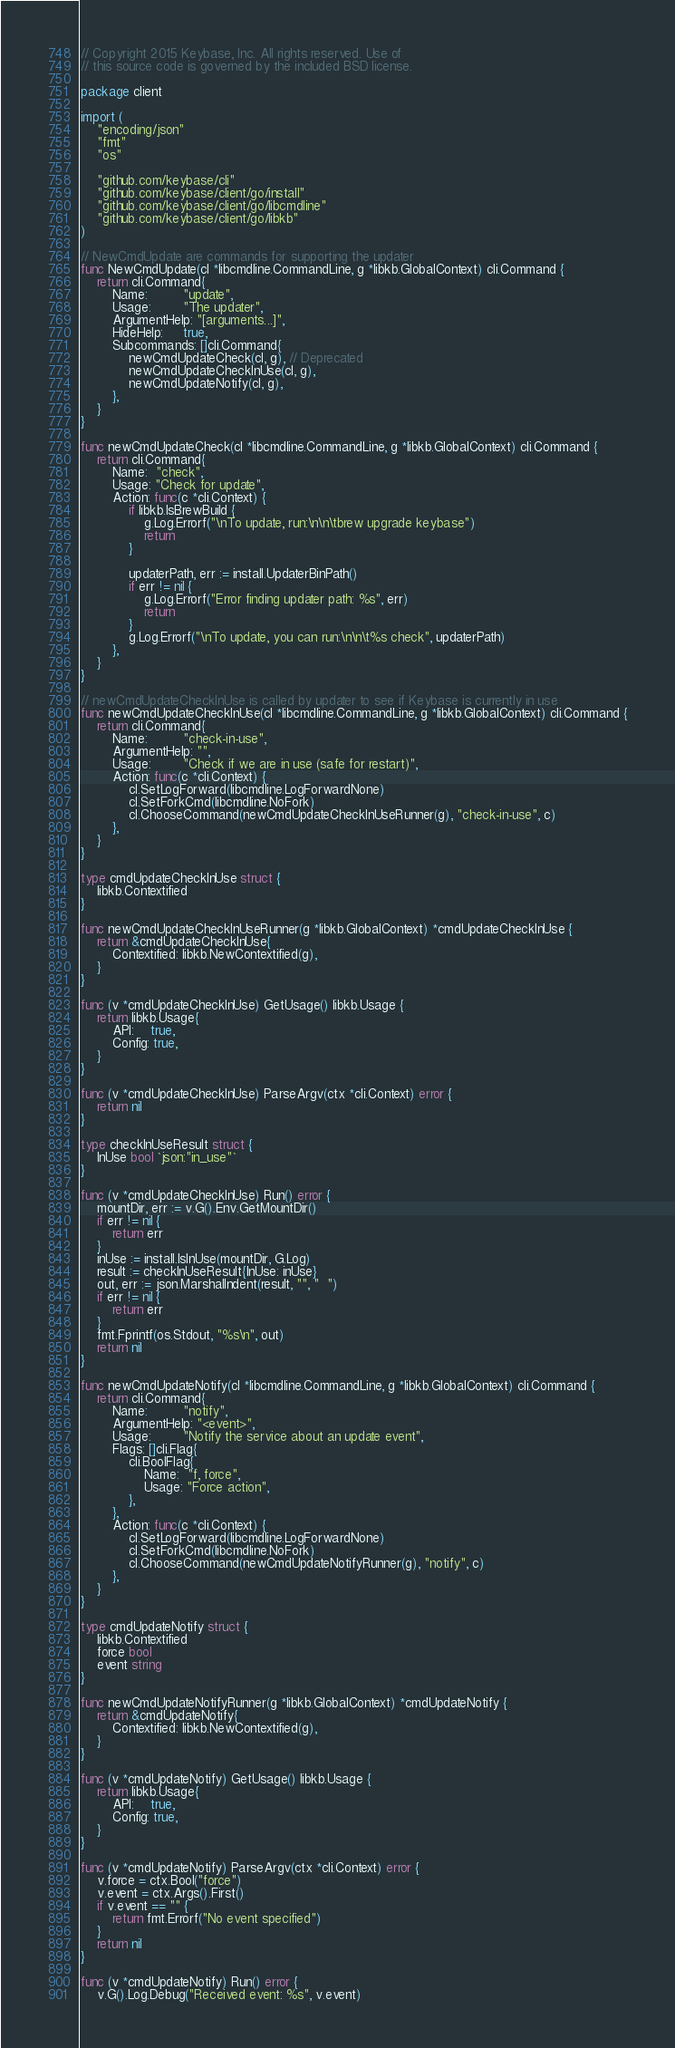<code> <loc_0><loc_0><loc_500><loc_500><_Go_>// Copyright 2015 Keybase, Inc. All rights reserved. Use of
// this source code is governed by the included BSD license.

package client

import (
	"encoding/json"
	"fmt"
	"os"

	"github.com/keybase/cli"
	"github.com/keybase/client/go/install"
	"github.com/keybase/client/go/libcmdline"
	"github.com/keybase/client/go/libkb"
)

// NewCmdUpdate are commands for supporting the updater
func NewCmdUpdate(cl *libcmdline.CommandLine, g *libkb.GlobalContext) cli.Command {
	return cli.Command{
		Name:         "update",
		Usage:        "The updater",
		ArgumentHelp: "[arguments...]",
		HideHelp:     true,
		Subcommands: []cli.Command{
			newCmdUpdateCheck(cl, g), // Deprecated
			newCmdUpdateCheckInUse(cl, g),
			newCmdUpdateNotify(cl, g),
		},
	}
}

func newCmdUpdateCheck(cl *libcmdline.CommandLine, g *libkb.GlobalContext) cli.Command {
	return cli.Command{
		Name:  "check",
		Usage: "Check for update",
		Action: func(c *cli.Context) {
			if libkb.IsBrewBuild {
				g.Log.Errorf("\nTo update, run:\n\n\tbrew upgrade keybase")
				return
			}

			updaterPath, err := install.UpdaterBinPath()
			if err != nil {
				g.Log.Errorf("Error finding updater path: %s", err)
				return
			}
			g.Log.Errorf("\nTo update, you can run:\n\n\t%s check", updaterPath)
		},
	}
}

// newCmdUpdateCheckInUse is called by updater to see if Keybase is currently in use
func newCmdUpdateCheckInUse(cl *libcmdline.CommandLine, g *libkb.GlobalContext) cli.Command {
	return cli.Command{
		Name:         "check-in-use",
		ArgumentHelp: "",
		Usage:        "Check if we are in use (safe for restart)",
		Action: func(c *cli.Context) {
			cl.SetLogForward(libcmdline.LogForwardNone)
			cl.SetForkCmd(libcmdline.NoFork)
			cl.ChooseCommand(newCmdUpdateCheckInUseRunner(g), "check-in-use", c)
		},
	}
}

type cmdUpdateCheckInUse struct {
	libkb.Contextified
}

func newCmdUpdateCheckInUseRunner(g *libkb.GlobalContext) *cmdUpdateCheckInUse {
	return &cmdUpdateCheckInUse{
		Contextified: libkb.NewContextified(g),
	}
}

func (v *cmdUpdateCheckInUse) GetUsage() libkb.Usage {
	return libkb.Usage{
		API:    true,
		Config: true,
	}
}

func (v *cmdUpdateCheckInUse) ParseArgv(ctx *cli.Context) error {
	return nil
}

type checkInUseResult struct {
	InUse bool `json:"in_use"`
}

func (v *cmdUpdateCheckInUse) Run() error {
	mountDir, err := v.G().Env.GetMountDir()
	if err != nil {
		return err
	}
	inUse := install.IsInUse(mountDir, G.Log)
	result := checkInUseResult{InUse: inUse}
	out, err := json.MarshalIndent(result, "", "  ")
	if err != nil {
		return err
	}
	fmt.Fprintf(os.Stdout, "%s\n", out)
	return nil
}

func newCmdUpdateNotify(cl *libcmdline.CommandLine, g *libkb.GlobalContext) cli.Command {
	return cli.Command{
		Name:         "notify",
		ArgumentHelp: "<event>",
		Usage:        "Notify the service about an update event",
		Flags: []cli.Flag{
			cli.BoolFlag{
				Name:  "f, force",
				Usage: "Force action",
			},
		},
		Action: func(c *cli.Context) {
			cl.SetLogForward(libcmdline.LogForwardNone)
			cl.SetForkCmd(libcmdline.NoFork)
			cl.ChooseCommand(newCmdUpdateNotifyRunner(g), "notify", c)
		},
	}
}

type cmdUpdateNotify struct {
	libkb.Contextified
	force bool
	event string
}

func newCmdUpdateNotifyRunner(g *libkb.GlobalContext) *cmdUpdateNotify {
	return &cmdUpdateNotify{
		Contextified: libkb.NewContextified(g),
	}
}

func (v *cmdUpdateNotify) GetUsage() libkb.Usage {
	return libkb.Usage{
		API:    true,
		Config: true,
	}
}

func (v *cmdUpdateNotify) ParseArgv(ctx *cli.Context) error {
	v.force = ctx.Bool("force")
	v.event = ctx.Args().First()
	if v.event == "" {
		return fmt.Errorf("No event specified")
	}
	return nil
}

func (v *cmdUpdateNotify) Run() error {
	v.G().Log.Debug("Received event: %s", v.event)</code> 